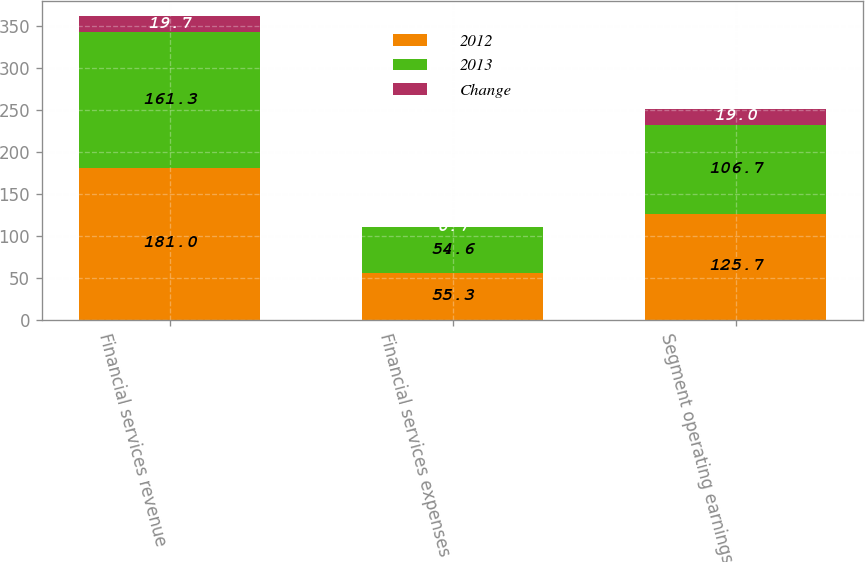Convert chart. <chart><loc_0><loc_0><loc_500><loc_500><stacked_bar_chart><ecel><fcel>Financial services revenue<fcel>Financial services expenses<fcel>Segment operating earnings<nl><fcel>2012<fcel>181<fcel>55.3<fcel>125.7<nl><fcel>2013<fcel>161.3<fcel>54.6<fcel>106.7<nl><fcel>Change<fcel>19.7<fcel>0.7<fcel>19<nl></chart> 